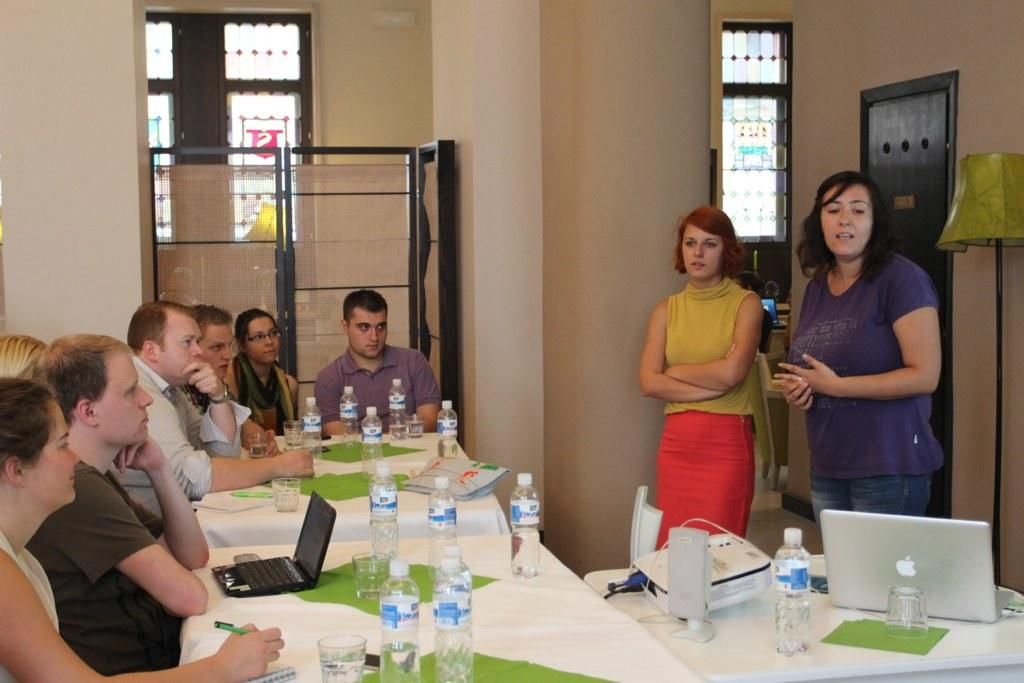What are the people in the image doing? There is a group of people seated on chairs in the image, which suggests they might be attending a meeting or presentation. Can you describe the people standing in the image? There are two women standing in the image. What electronic device is visible in the image? A laptop is visible in the image. What device might be used to display visuals in the image? A projector is present in the image. What items are available for hydration in the image? There are water bottles in the image. What type of materials can be seen on the table in the image? There are papers on the table in the image. What type of rhythm is being played by the actor in the image? There is no actor or rhythm present in the image. Where is the library located in the image? There is no library present in the image. 